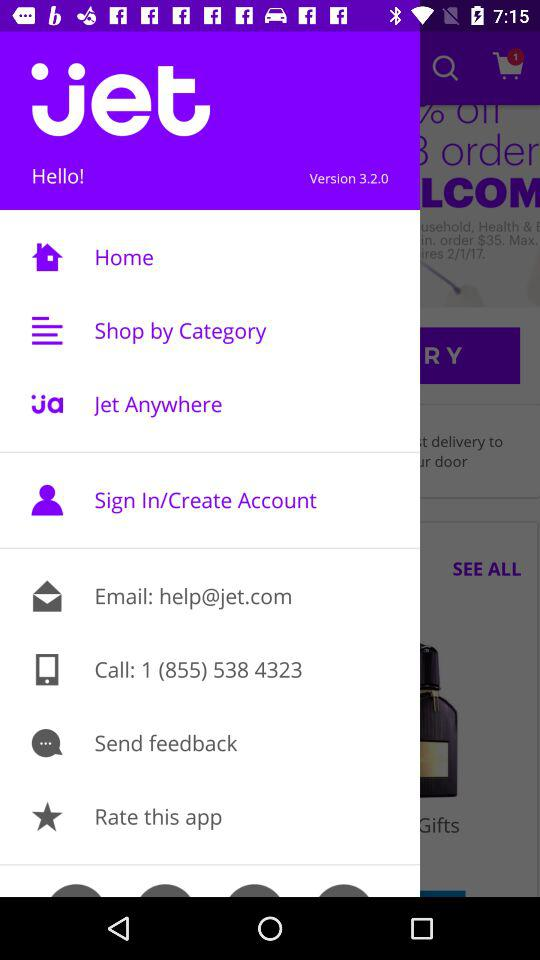How many stars does the application have?
When the provided information is insufficient, respond with <no answer>. <no answer> 